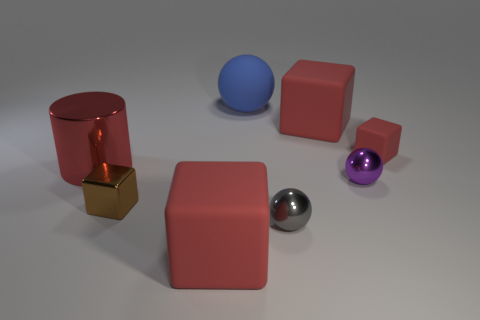How many things are either gray metallic balls or small shiny things?
Make the answer very short. 3. There is a cube that is in front of the large red cylinder and right of the brown cube; what is its size?
Offer a terse response. Large. Is the number of small purple metallic balls to the right of the small red rubber thing less than the number of small purple balls?
Give a very brief answer. Yes. What shape is the other large object that is made of the same material as the brown object?
Offer a terse response. Cylinder. There is a big red matte thing that is to the right of the blue sphere; is its shape the same as the big rubber thing that is in front of the small red matte cube?
Provide a succinct answer. Yes. Are there fewer blocks behind the blue thing than tiny brown metallic cubes behind the red metal object?
Keep it short and to the point. No. What shape is the tiny rubber thing that is the same color as the big cylinder?
Your answer should be very brief. Cube. What number of other shiny blocks are the same size as the shiny block?
Keep it short and to the point. 0. Is the object to the left of the small metallic block made of the same material as the brown thing?
Offer a very short reply. Yes. Are there any blue rubber objects?
Your answer should be compact. Yes. 